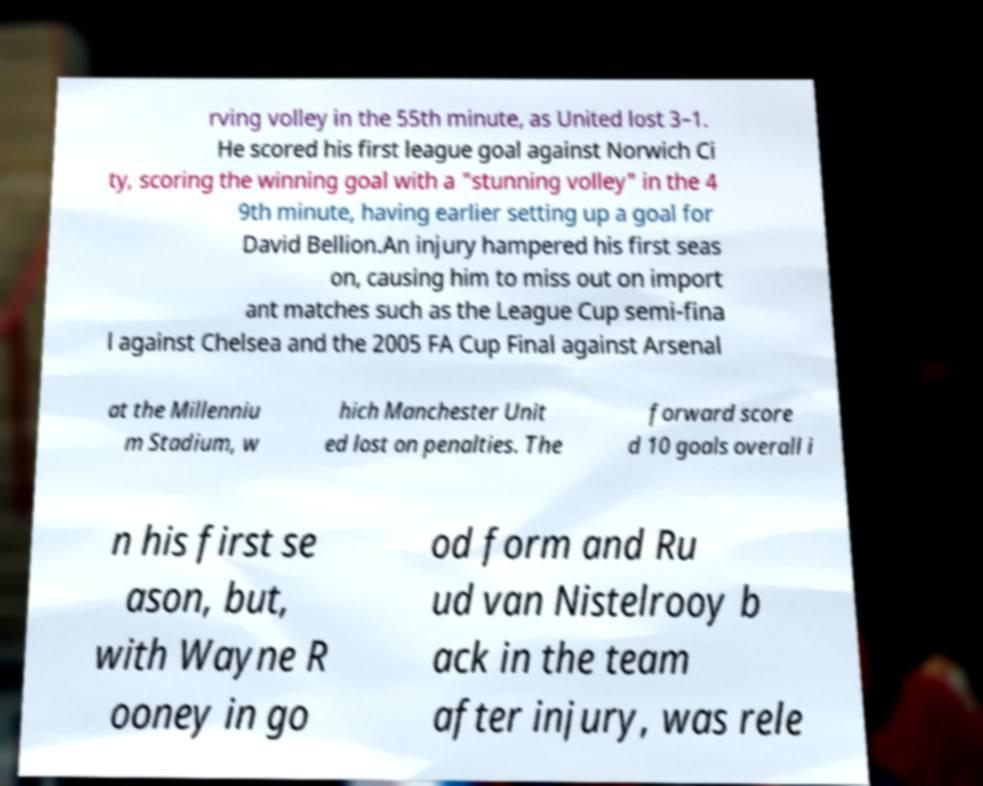What messages or text are displayed in this image? I need them in a readable, typed format. rving volley in the 55th minute, as United lost 3–1. He scored his first league goal against Norwich Ci ty, scoring the winning goal with a "stunning volley" in the 4 9th minute, having earlier setting up a goal for David Bellion.An injury hampered his first seas on, causing him to miss out on import ant matches such as the League Cup semi-fina l against Chelsea and the 2005 FA Cup Final against Arsenal at the Millenniu m Stadium, w hich Manchester Unit ed lost on penalties. The forward score d 10 goals overall i n his first se ason, but, with Wayne R ooney in go od form and Ru ud van Nistelrooy b ack in the team after injury, was rele 